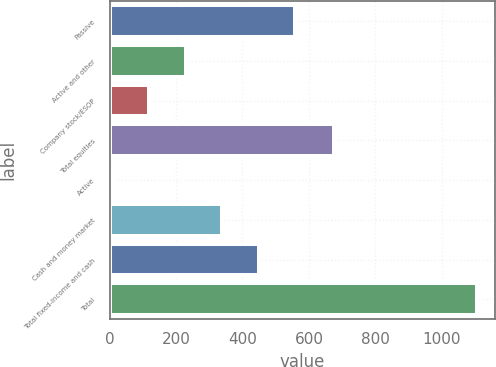Convert chart to OTSL. <chart><loc_0><loc_0><loc_500><loc_500><bar_chart><fcel>Passive<fcel>Active and other<fcel>Company stock/ESOP<fcel>Total equities<fcel>Active<fcel>Cash and money market<fcel>Total fixed-income and cash<fcel>Total<nl><fcel>558.2<fcel>229.2<fcel>119.6<fcel>676<fcel>10<fcel>339<fcel>448.6<fcel>1106<nl></chart> 